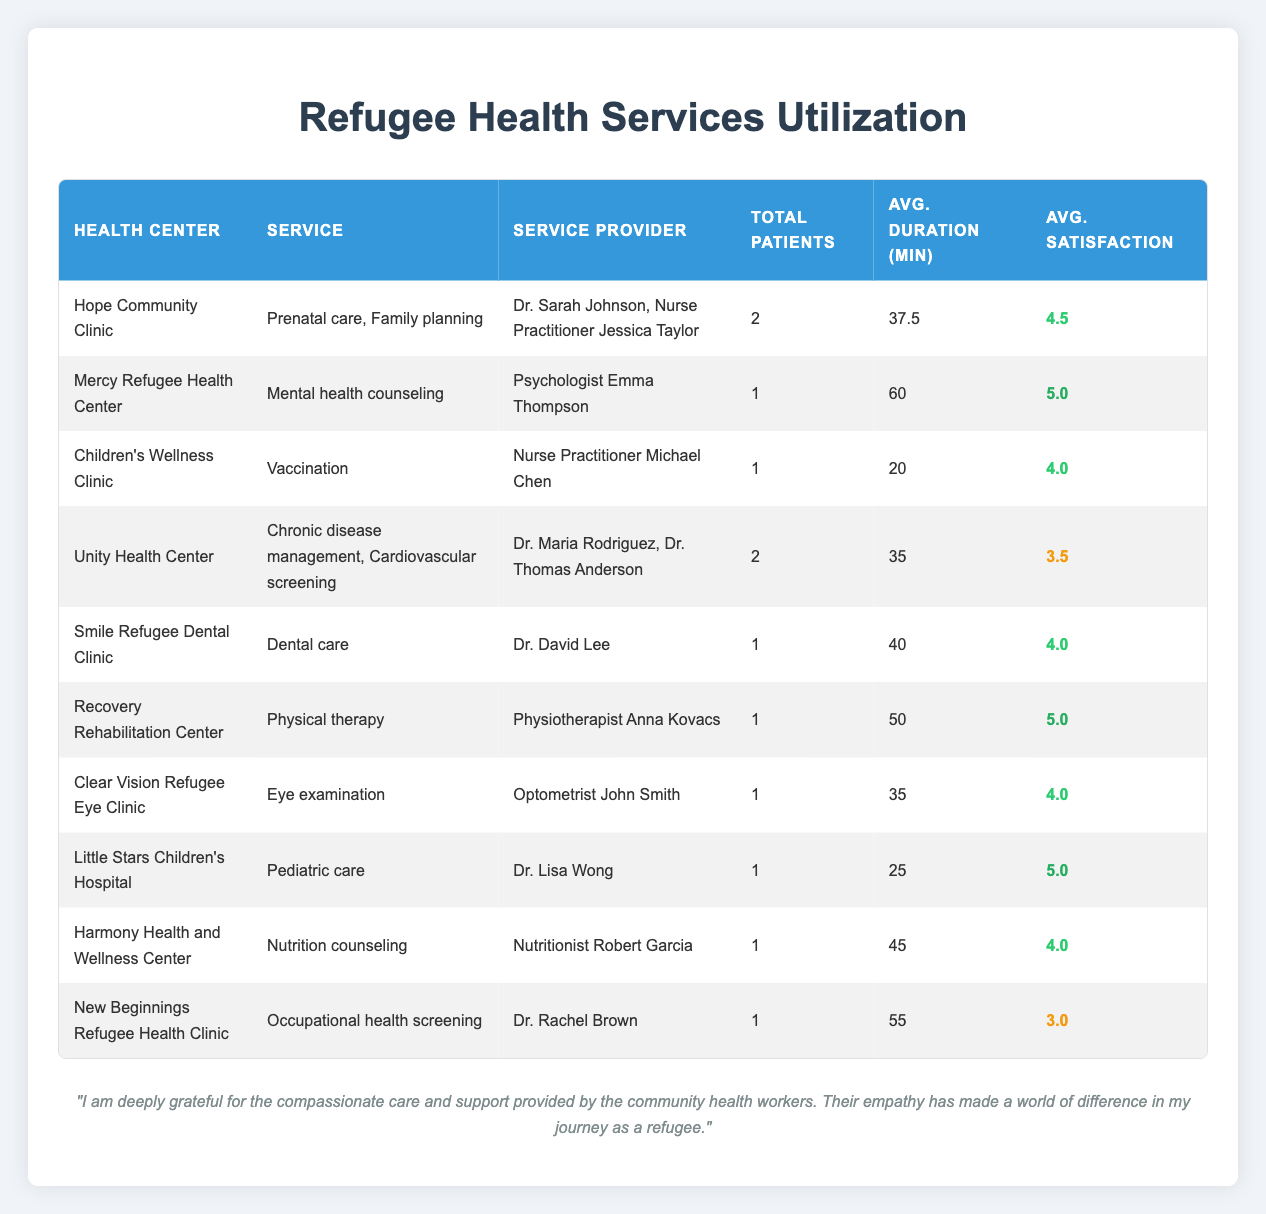What is the total number of patients who received services at the Unity Health Center? There are two services listed under the Unity Health Center: Chronic disease management and Cardiovascular screening. Each service has one patient associated with it, totaling 2 patients.
Answer: 2 Which health center provided mental health counseling? The Mercy Refugee Health Center is the only center listed that provided mental health counseling according to the table.
Answer: Mercy Refugee Health Center What is the average satisfaction rating for services provided at the Smile Refugee Dental Clinic? The only service offered at the Smile Refugee Dental Clinic is dental care, and it has a satisfaction rating of 4. Therefore, the average satisfaction rating remains 4.
Answer: 4 How many health centers had an average satisfaction rating of 4 or higher? The following health centers have an average satisfaction of 4 or higher: Hope Community Clinic (4.5), Mercy Refugee Health Center (5.0), Children's Wellness Clinic (4.0), Smile Refugee Dental Clinic (4.0), and Harmony Health and Wellness Center (4.0). Counting these gives us 5 health centers.
Answer: 5 Is there any health center that had a patient with an average satisfaction of 3 or lower? Yes, the New Beginnings Refugee Health Clinic had a patient with an average satisfaction of 3, which is below the threshold.
Answer: Yes What is the total average duration of services provided at health centers that received feedback ratings of 5? The health centers with an average satisfaction rating of 5 are: Mercy Refugee Health Center (60 min), Recovery Rehabilitation Center (50 min), and Little Stars Children's Hospital (25 min). The total duration is 60 + 50 + 25 = 135 min. To find the average, we divide by 3 (the number of health centers), which is 135/3 = 45 min.
Answer: 45 min Which health center had the longest average duration of service provided, and what was that duration? When checking the table, Mercy Refugee Health Center has the longest average duration of service at 60 minutes.
Answer: 60 min How many different services were provided at the Hope Community Clinic? There are two services listed under the Hope Community Clinic: Prenatal care and Family planning. Therefore, the number of different services provided is 2.
Answer: 2 What was the age of the youngest patient that visited the Children's Wellness Clinic? According to the table, the only patient listed for the Children's Wellness Clinic is Fatima Mohamed, who is 7 years old. Therefore, she is the youngest patient.
Answer: 7 years old 